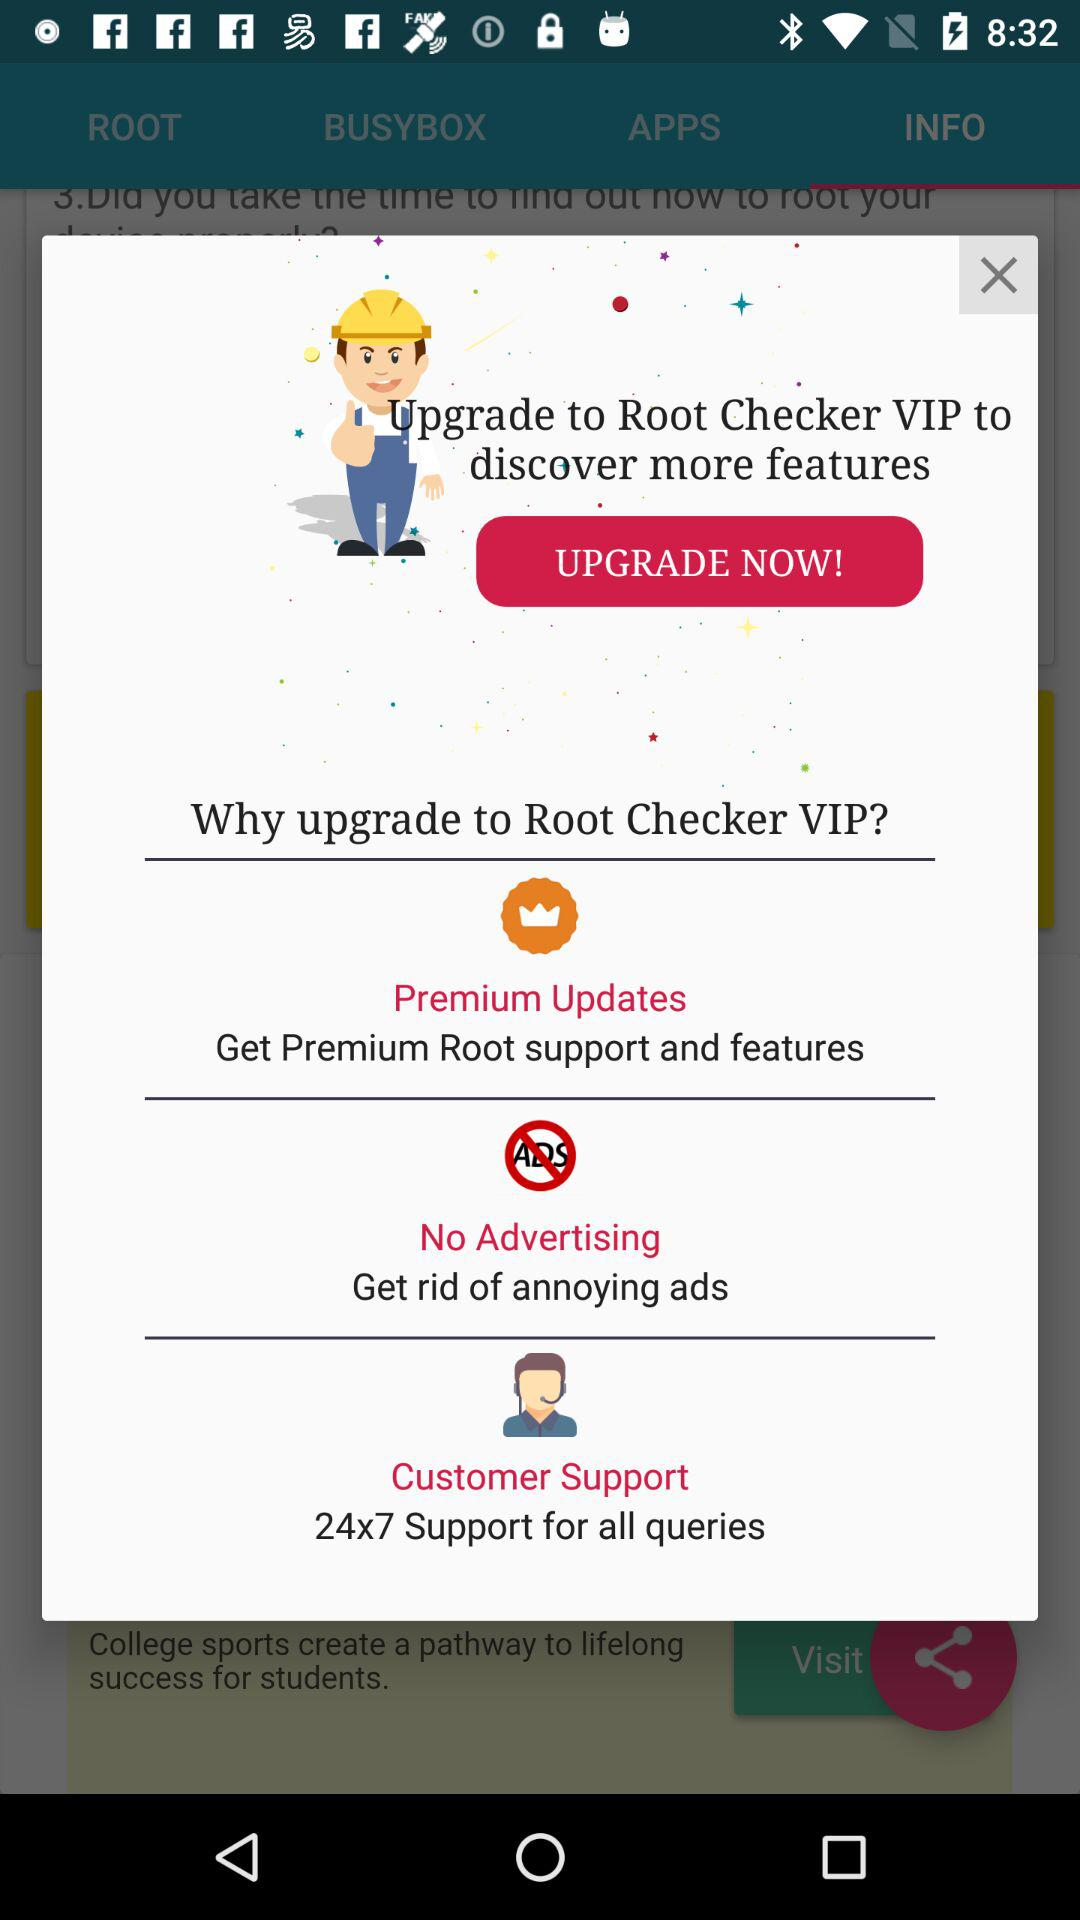What is the customer support timing? The customer support timing is 24x7. 